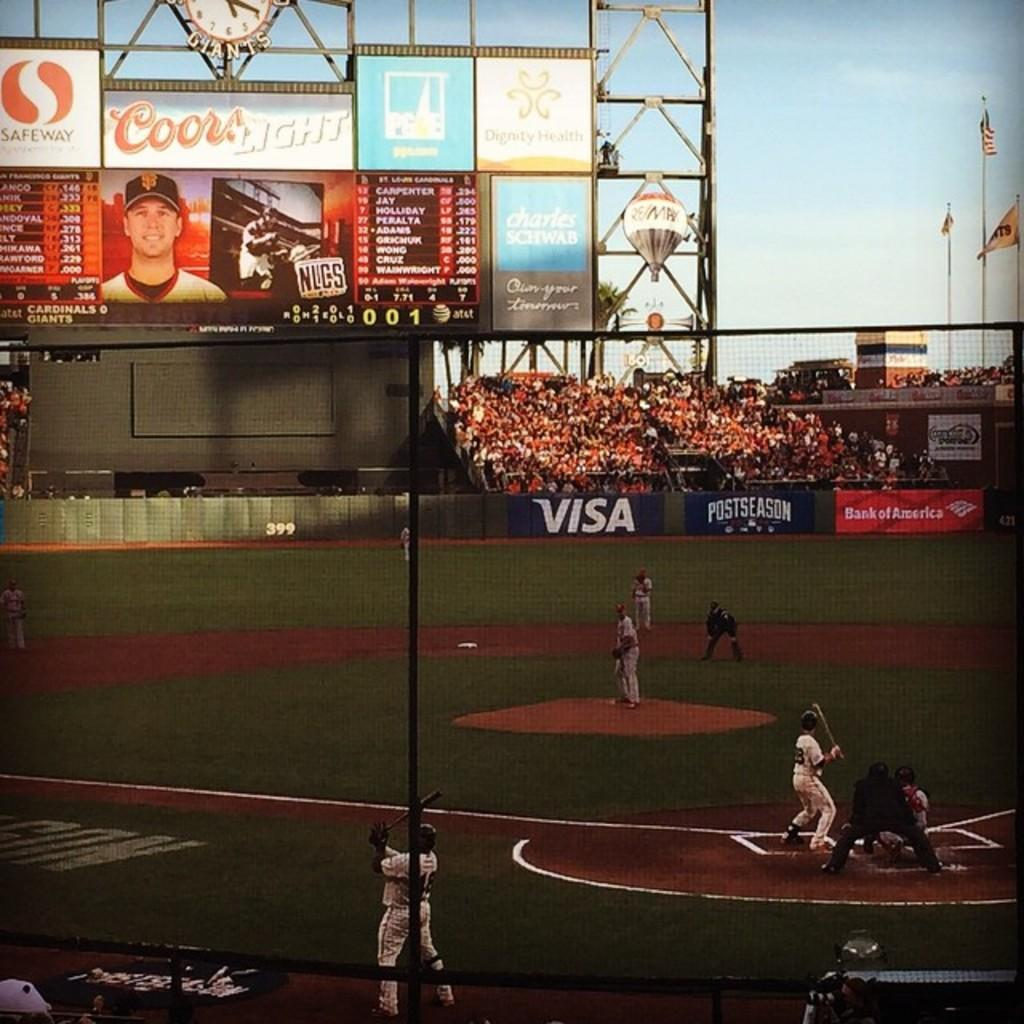Provide a one-sentence caption for the provided image. baseball players on a field sponsored by Visa and Coors. 